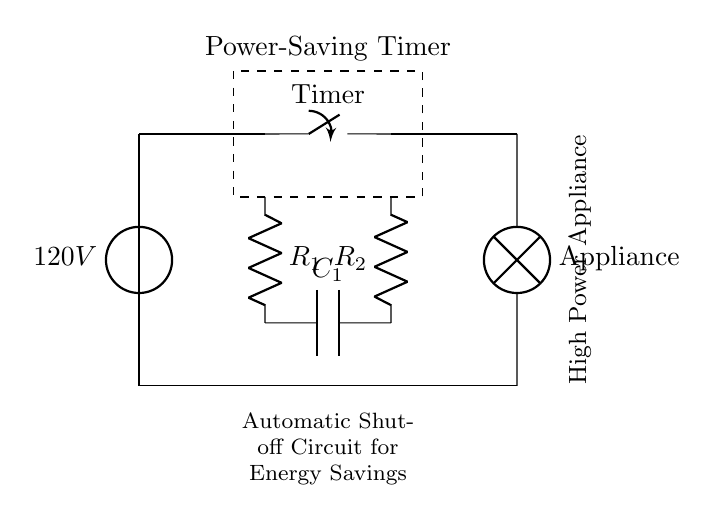What type of appliance is represented in the diagram? The diagram represents a high power appliance, as indicated by the label next to it in the circuit.
Answer: High power appliance What is the voltage source in the circuit? The voltage source is labeled as 120V, which defines the potential difference supplied to the circuit.
Answer: 120V What is the purpose of the timer component in this circuit? The timer, indicated by the switch labeled "Timer", serves the role of controlling the on/off status of the appliance based on a set time, contributing to energy savings.
Answer: Control of shut-off How many resistors are shown in the circuit? There are two resistors in the circuit, labeled R1 and R2, as directly observed in the diagram.
Answer: Two What component is used to reduce energy consumption automatically? The timer switch component is responsible for the automatic shut-off, which helps in reducing energy consumption by turning the appliance off after a specified duration.
Answer: Timer switch What is the primary function of the capacitor in this circuit? The capacitor labeled C1 helps in smoothing and storing charge, which can be vital for the timer function to operate efficiently by providing a timed delay for the shut-off action.
Answer: Store charge What does the dashed rectangle signify in the diagram? The dashed rectangle indicates the section or area dedicated to the power-saving timer, encapsulating the associated components within it.
Answer: Power-saving timer 